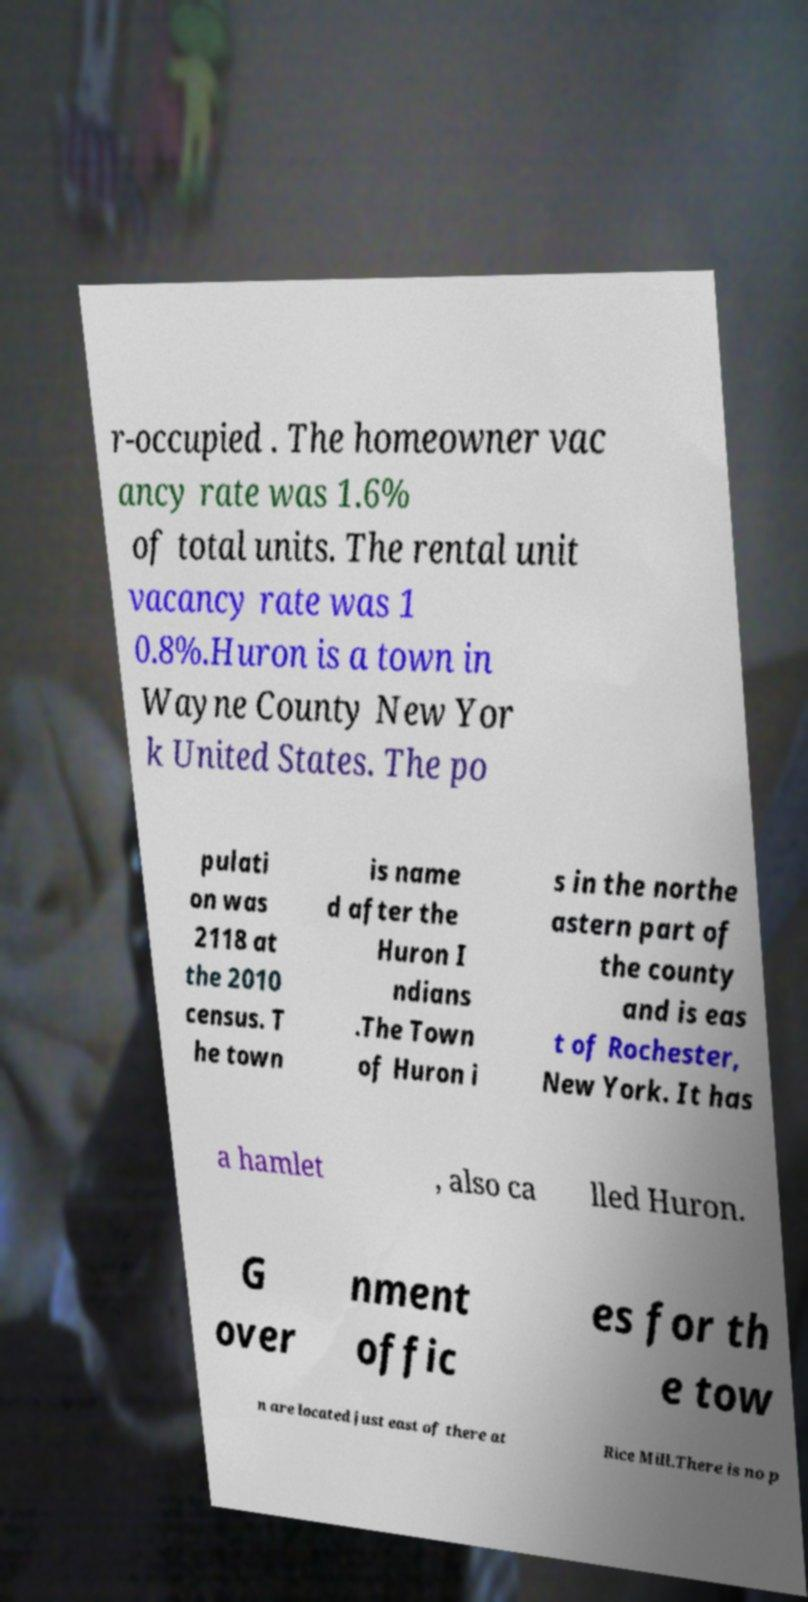Please read and relay the text visible in this image. What does it say? r-occupied . The homeowner vac ancy rate was 1.6% of total units. The rental unit vacancy rate was 1 0.8%.Huron is a town in Wayne County New Yor k United States. The po pulati on was 2118 at the 2010 census. T he town is name d after the Huron I ndians .The Town of Huron i s in the northe astern part of the county and is eas t of Rochester, New York. It has a hamlet , also ca lled Huron. G over nment offic es for th e tow n are located just east of there at Rice Mill.There is no p 